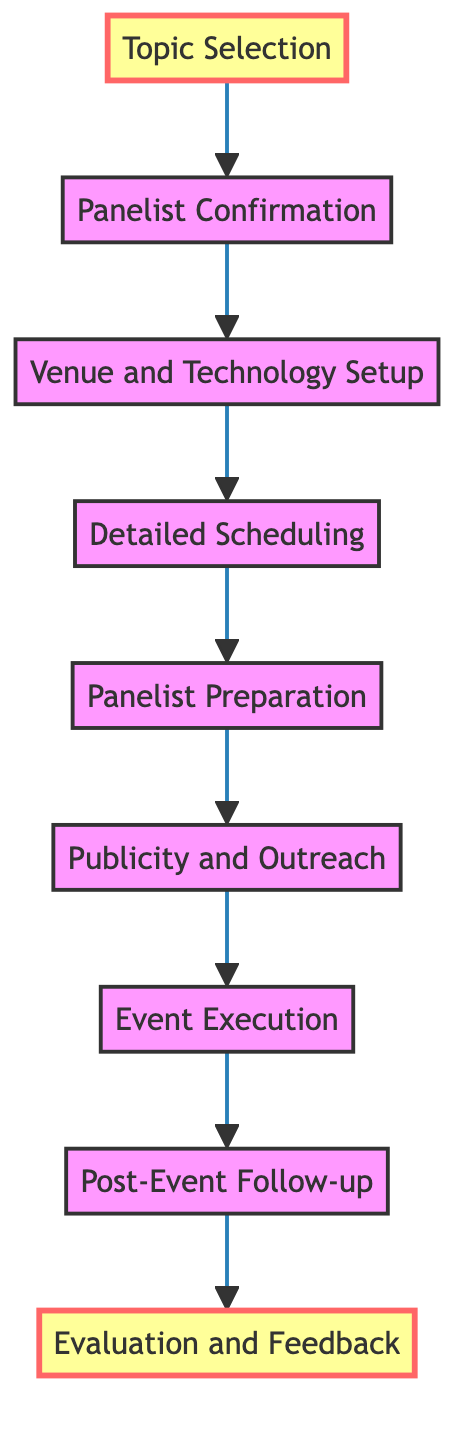What is the first step in the panel organization process? The diagram indicates that the first step is "Topic Selection," which is the initial action required to start planning the panel.
Answer: Topic Selection How many nodes are present in the diagram? By counting the elements listed in the flow chart, including each step from Topic Selection to Evaluation and Feedback, we find there are a total of 9 nodes.
Answer: 9 What follows after "Event Execution"? From the flowchart's progression, the step that comes immediately after "Event Execution" is "Post-Event Follow-up."
Answer: Post-Event Follow-up What is the last step in the diagram? The flow chart leads to the final step being "Evaluation and Feedback," which is depicted at the top of the diagram as the concluding action.
Answer: Evaluation and Feedback Which step emphasizes the role of community input? The "Topic Selection" step is directly related to community engagement as it involves identifying relevant issues based on stakeholders' input.
Answer: Topic Selection What is the relationship between "Publicity and Outreach" and "Event Execution"? The relationship is sequential; "Publicity and Outreach" must occur prior to "Event Execution," as the focus on marketing is necessary before managing the actual event logistics.
Answer: Sequential How many steps are between "Panelist Confirmation" and "Publicity and Outreach"? There are two steps in the flow from "Panelist Confirmation" to "Publicity and Outreach": "Venue and Technology Setup" and "Detailed Scheduling."
Answer: 2 What objective does "Panelist Preparation" serve in the flow? "Panelist Preparation" is designed to ensure panelists are briefed and understand the session goals before the actual event takes place, facilitating a smooth discussion.
Answer: Ensure panelists are briefed What does the diagram suggest happens after obtaining feedback? The final action following "Evaluation and Feedback" implies a cycle of improvement and may involve taking the feedback into account for future events, though it's not explicitly detailed as a node in this diagram.
Answer: Future improvement (implied) 